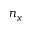<formula> <loc_0><loc_0><loc_500><loc_500>n _ { x }</formula> 